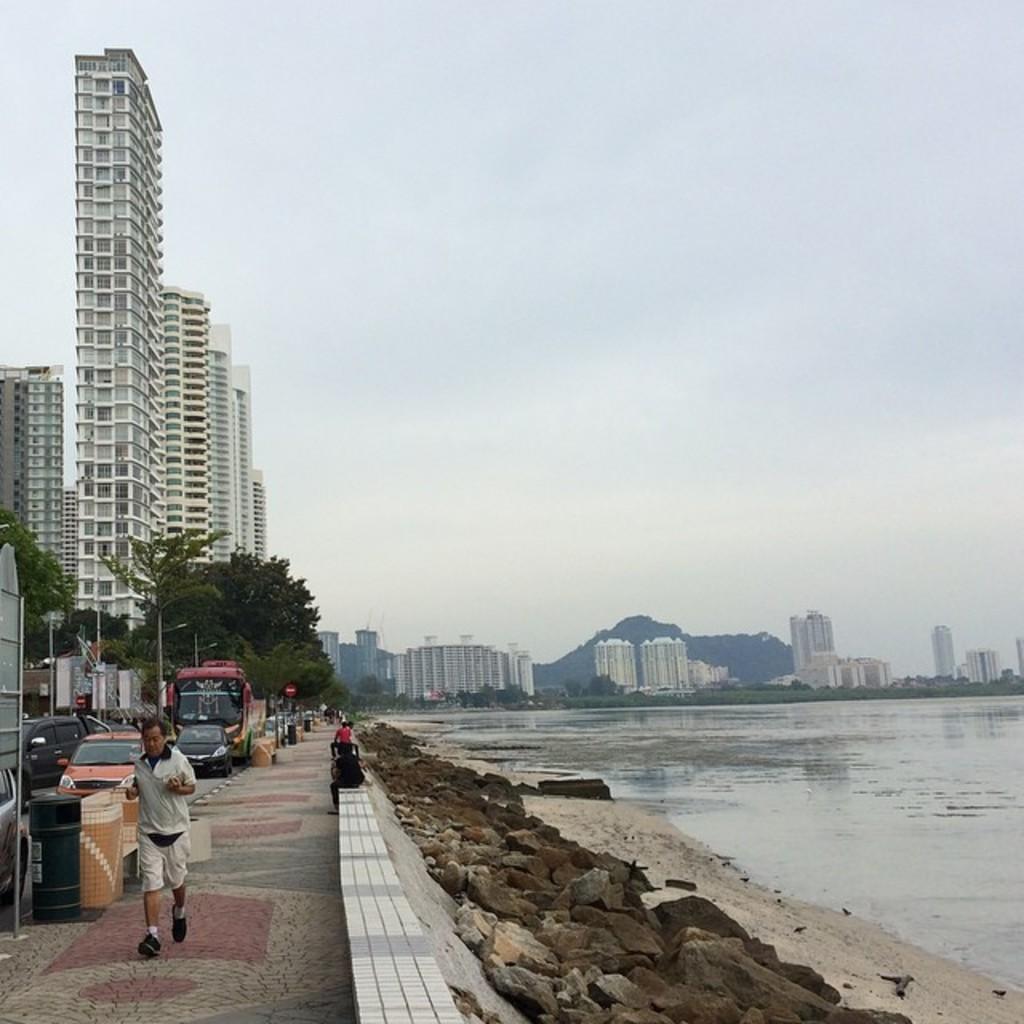Describe this image in one or two sentences. This picture is clicked outside. On the right we can see a water body and the rocks. On the left we can see the group of people, vehicles, trees, poles, buildings and some other objects. In the background we can see the sky, trees, buildings and some other objects. 